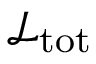Convert formula to latex. <formula><loc_0><loc_0><loc_500><loc_500>{ \mathcal { L } } _ { t o t }</formula> 